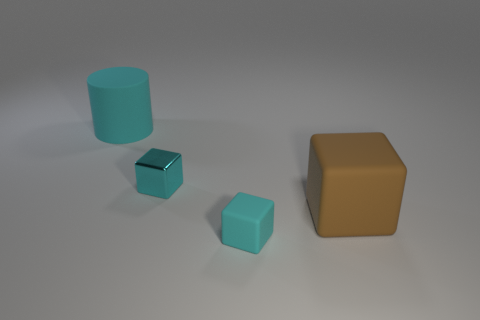What is the size of the matte cube that is the same color as the tiny metallic cube?
Provide a short and direct response. Small. What is the shape of the big thing that is the same color as the tiny rubber object?
Provide a succinct answer. Cylinder. Are there the same number of cyan rubber objects on the left side of the big cyan thing and yellow blocks?
Ensure brevity in your answer.  Yes. There is a rubber object behind the metallic thing; what size is it?
Make the answer very short. Large. What number of small objects are cubes or yellow matte balls?
Provide a short and direct response. 2. What is the color of the other rubber object that is the same shape as the large brown matte thing?
Your answer should be compact. Cyan. Is the cylinder the same size as the brown rubber block?
Offer a terse response. Yes. How many objects are small metallic blocks or cyan matte things that are in front of the cyan cylinder?
Ensure brevity in your answer.  2. The small cube that is behind the matte block that is left of the big brown rubber thing is what color?
Make the answer very short. Cyan. Does the rubber block that is in front of the brown rubber object have the same color as the big cylinder?
Provide a succinct answer. Yes. 